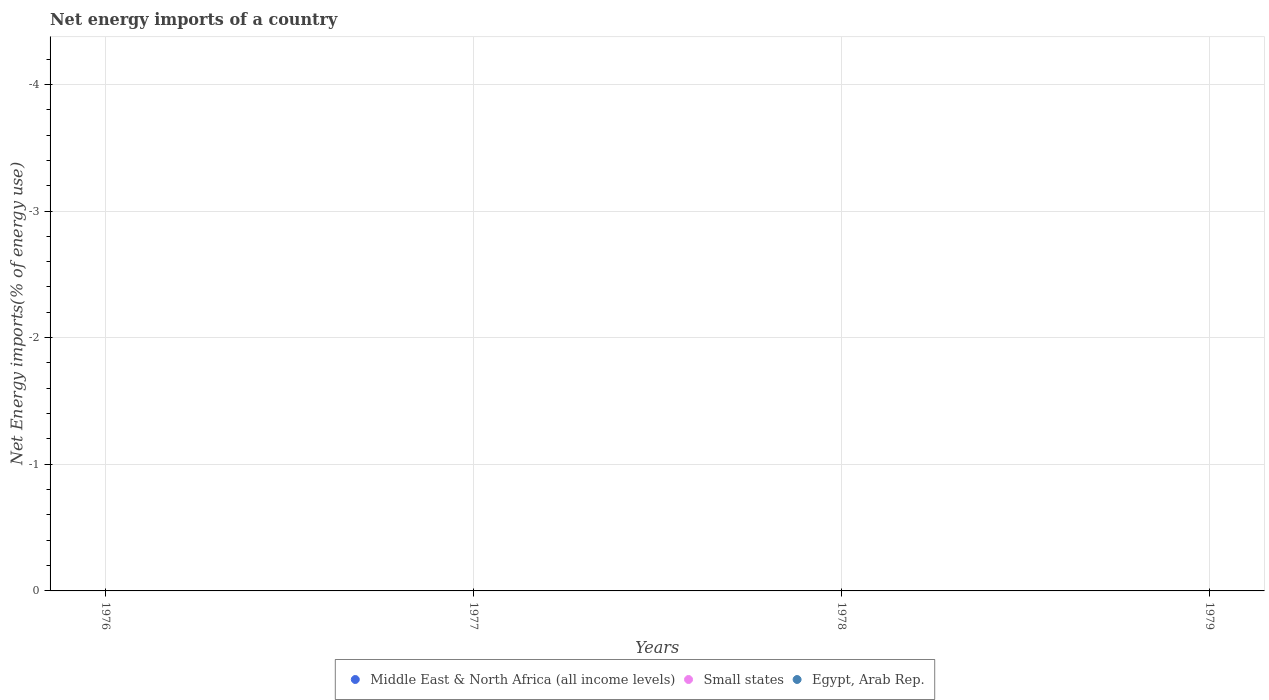Is the number of dotlines equal to the number of legend labels?
Provide a short and direct response. No. Across all years, what is the minimum net energy imports in Egypt, Arab Rep.?
Offer a terse response. 0. What is the total net energy imports in Egypt, Arab Rep. in the graph?
Give a very brief answer. 0. In how many years, is the net energy imports in Small states greater than -2.4 %?
Your answer should be very brief. 0. In how many years, is the net energy imports in Middle East & North Africa (all income levels) greater than the average net energy imports in Middle East & North Africa (all income levels) taken over all years?
Provide a short and direct response. 0. Is it the case that in every year, the sum of the net energy imports in Small states and net energy imports in Egypt, Arab Rep.  is greater than the net energy imports in Middle East & North Africa (all income levels)?
Offer a terse response. No. Does the net energy imports in Egypt, Arab Rep. monotonically increase over the years?
Give a very brief answer. No. Is the net energy imports in Egypt, Arab Rep. strictly greater than the net energy imports in Middle East & North Africa (all income levels) over the years?
Offer a terse response. Yes. Is the net energy imports in Middle East & North Africa (all income levels) strictly less than the net energy imports in Egypt, Arab Rep. over the years?
Your answer should be very brief. Yes. How many years are there in the graph?
Offer a terse response. 4. What is the difference between two consecutive major ticks on the Y-axis?
Your answer should be very brief. 1. Are the values on the major ticks of Y-axis written in scientific E-notation?
Make the answer very short. No. Does the graph contain any zero values?
Provide a short and direct response. Yes. Does the graph contain grids?
Your response must be concise. Yes. How are the legend labels stacked?
Your answer should be very brief. Horizontal. What is the title of the graph?
Your answer should be very brief. Net energy imports of a country. What is the label or title of the Y-axis?
Make the answer very short. Net Energy imports(% of energy use). What is the Net Energy imports(% of energy use) in Small states in 1976?
Provide a short and direct response. 0. What is the Net Energy imports(% of energy use) of Egypt, Arab Rep. in 1976?
Your answer should be very brief. 0. What is the Net Energy imports(% of energy use) in Small states in 1977?
Keep it short and to the point. 0. What is the Net Energy imports(% of energy use) in Egypt, Arab Rep. in 1977?
Provide a short and direct response. 0. What is the Net Energy imports(% of energy use) of Middle East & North Africa (all income levels) in 1978?
Your response must be concise. 0. What is the Net Energy imports(% of energy use) of Egypt, Arab Rep. in 1978?
Ensure brevity in your answer.  0. What is the Net Energy imports(% of energy use) in Small states in 1979?
Your answer should be compact. 0. What is the total Net Energy imports(% of energy use) in Middle East & North Africa (all income levels) in the graph?
Make the answer very short. 0. What is the total Net Energy imports(% of energy use) in Egypt, Arab Rep. in the graph?
Your answer should be very brief. 0. What is the average Net Energy imports(% of energy use) in Middle East & North Africa (all income levels) per year?
Make the answer very short. 0. 